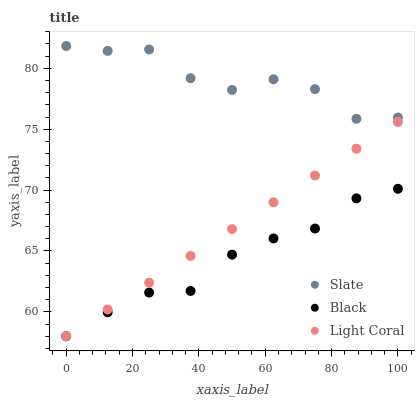Does Black have the minimum area under the curve?
Answer yes or no. Yes. Does Slate have the maximum area under the curve?
Answer yes or no. Yes. Does Slate have the minimum area under the curve?
Answer yes or no. No. Does Black have the maximum area under the curve?
Answer yes or no. No. Is Light Coral the smoothest?
Answer yes or no. Yes. Is Slate the roughest?
Answer yes or no. Yes. Is Black the smoothest?
Answer yes or no. No. Is Black the roughest?
Answer yes or no. No. Does Light Coral have the lowest value?
Answer yes or no. Yes. Does Slate have the lowest value?
Answer yes or no. No. Does Slate have the highest value?
Answer yes or no. Yes. Does Black have the highest value?
Answer yes or no. No. Is Black less than Slate?
Answer yes or no. Yes. Is Slate greater than Light Coral?
Answer yes or no. Yes. Does Black intersect Light Coral?
Answer yes or no. Yes. Is Black less than Light Coral?
Answer yes or no. No. Is Black greater than Light Coral?
Answer yes or no. No. Does Black intersect Slate?
Answer yes or no. No. 